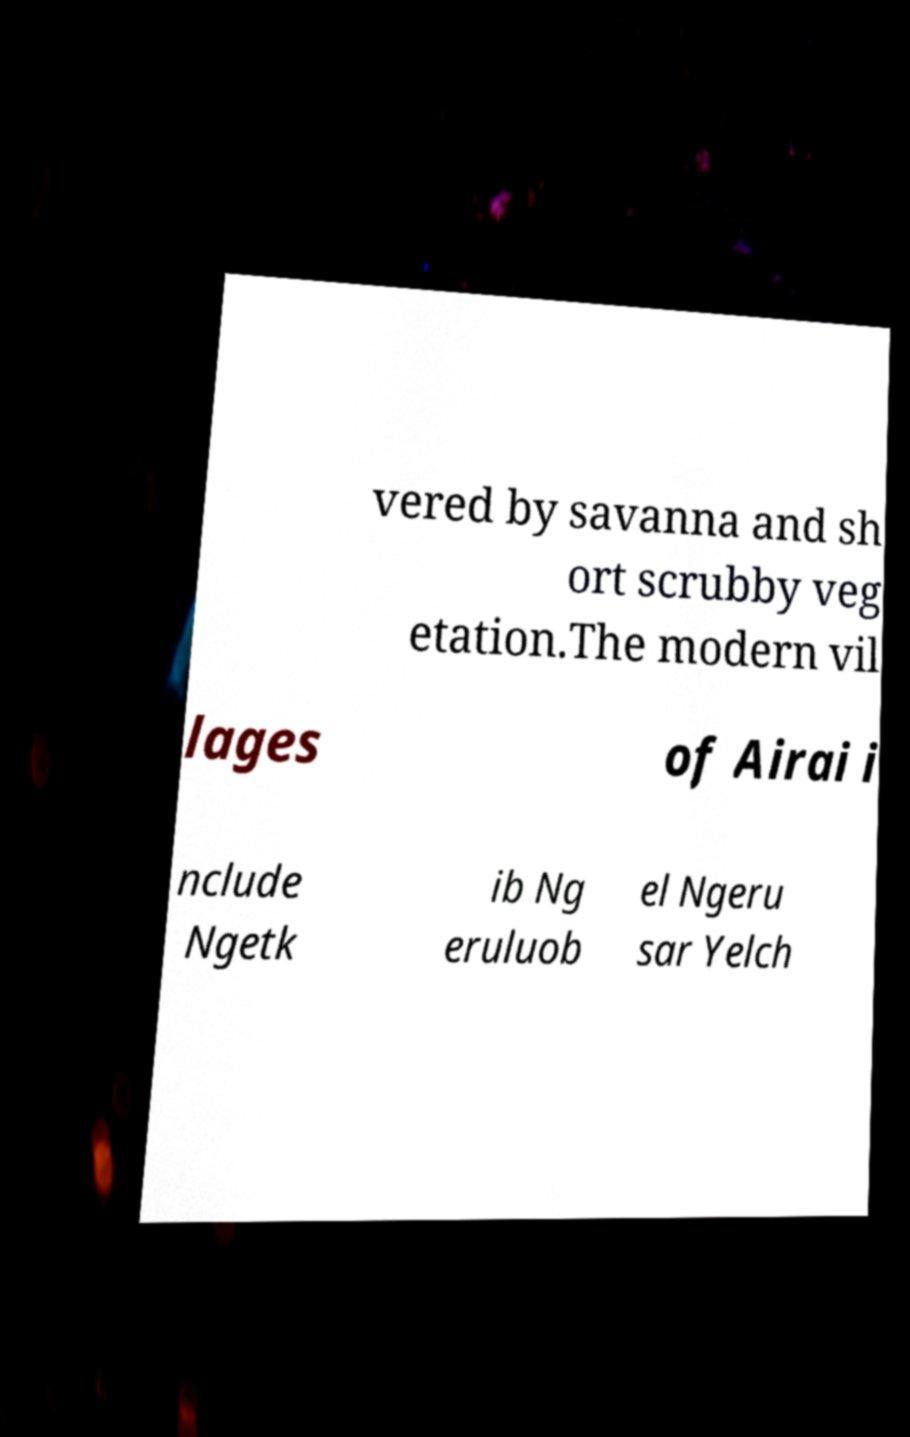I need the written content from this picture converted into text. Can you do that? vered by savanna and sh ort scrubby veg etation.The modern vil lages of Airai i nclude Ngetk ib Ng eruluob el Ngeru sar Yelch 